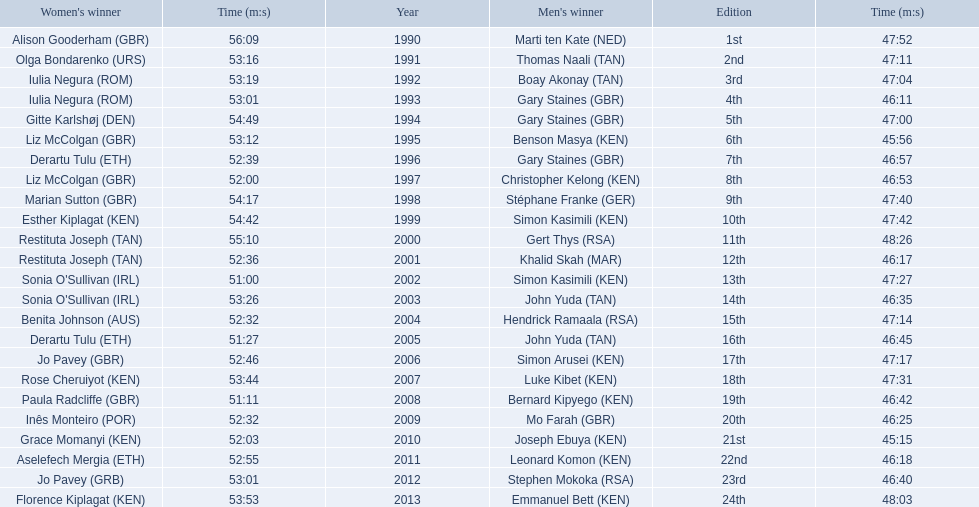Which of the runner in the great south run were women? Alison Gooderham (GBR), Olga Bondarenko (URS), Iulia Negura (ROM), Iulia Negura (ROM), Gitte Karlshøj (DEN), Liz McColgan (GBR), Derartu Tulu (ETH), Liz McColgan (GBR), Marian Sutton (GBR), Esther Kiplagat (KEN), Restituta Joseph (TAN), Restituta Joseph (TAN), Sonia O'Sullivan (IRL), Sonia O'Sullivan (IRL), Benita Johnson (AUS), Derartu Tulu (ETH), Jo Pavey (GBR), Rose Cheruiyot (KEN), Paula Radcliffe (GBR), Inês Monteiro (POR), Grace Momanyi (KEN), Aselefech Mergia (ETH), Jo Pavey (GRB), Florence Kiplagat (KEN). Of those women, which ones had a time of at least 53 minutes? Alison Gooderham (GBR), Olga Bondarenko (URS), Iulia Negura (ROM), Iulia Negura (ROM), Gitte Karlshøj (DEN), Liz McColgan (GBR), Marian Sutton (GBR), Esther Kiplagat (KEN), Restituta Joseph (TAN), Sonia O'Sullivan (IRL), Rose Cheruiyot (KEN), Jo Pavey (GRB), Florence Kiplagat (KEN). Between those women, which ones did not go over 53 minutes? Olga Bondarenko (URS), Iulia Negura (ROM), Iulia Negura (ROM), Liz McColgan (GBR), Sonia O'Sullivan (IRL), Rose Cheruiyot (KEN), Jo Pavey (GRB), Florence Kiplagat (KEN). Of those 8, what were the three slowest times? Sonia O'Sullivan (IRL), Rose Cheruiyot (KEN), Florence Kiplagat (KEN). Between only those 3 women, which runner had the fastest time? Sonia O'Sullivan (IRL). What was this women's time? 53:26. 